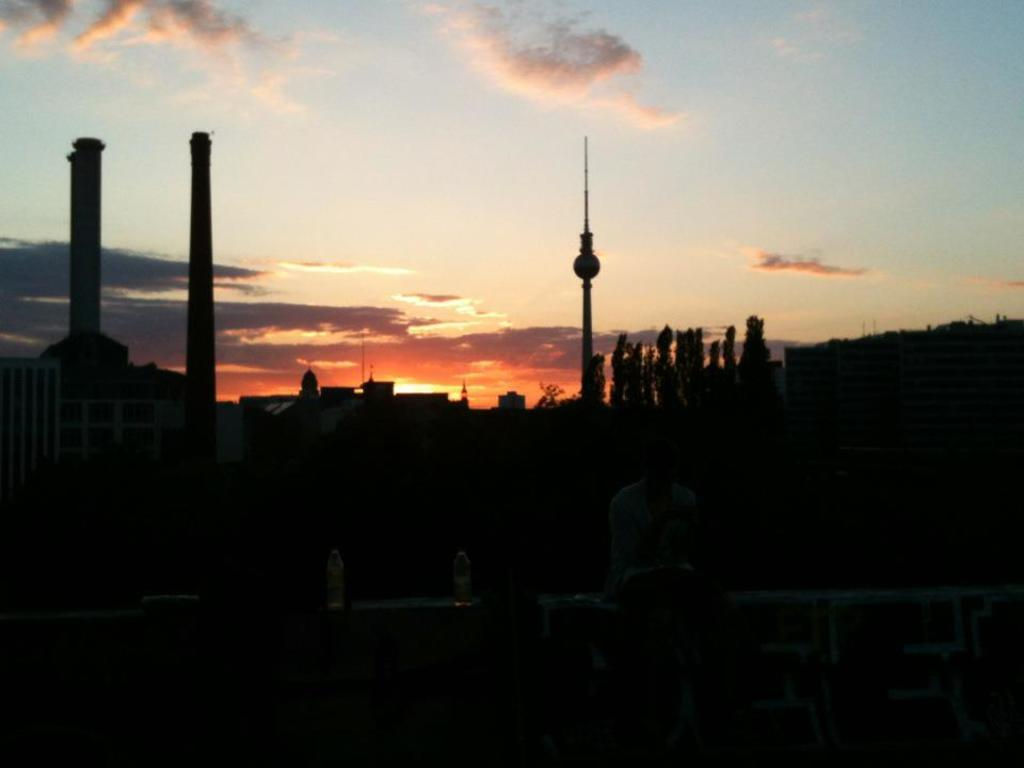What type of structure is visible in the image? There is a building with chimneys in the image. Where was the image likely taken? The image was likely taken outside. How would you describe the lighting in the image? The image is dark. What can be seen in the sky in the background of the image? There are clouds in the sky in the background of the image. How many cabbages are hanging from the chimneys in the image? There are no cabbages present in the image; it features a building with chimneys. What type of pin is used to hold the clouds in place in the image? There is no pin present in the image; the clouds are naturally in the sky. 